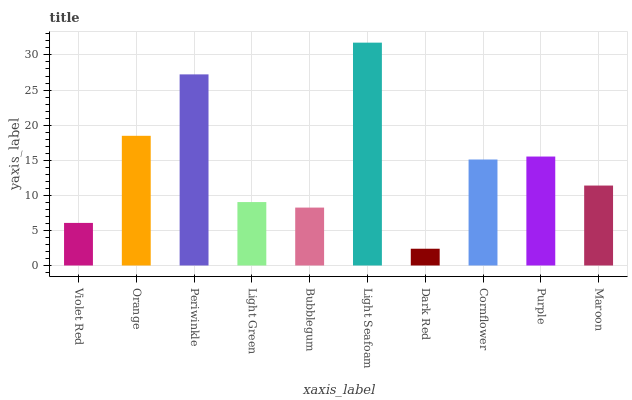Is Orange the minimum?
Answer yes or no. No. Is Orange the maximum?
Answer yes or no. No. Is Orange greater than Violet Red?
Answer yes or no. Yes. Is Violet Red less than Orange?
Answer yes or no. Yes. Is Violet Red greater than Orange?
Answer yes or no. No. Is Orange less than Violet Red?
Answer yes or no. No. Is Cornflower the high median?
Answer yes or no. Yes. Is Maroon the low median?
Answer yes or no. Yes. Is Dark Red the high median?
Answer yes or no. No. Is Bubblegum the low median?
Answer yes or no. No. 